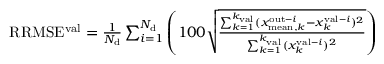Convert formula to latex. <formula><loc_0><loc_0><loc_500><loc_500>\begin{array} { r } { R R M S E ^ { v a l } = \frac { 1 } { N _ { d } } \sum _ { i = 1 } ^ { N _ { d } } \left ( 1 0 0 \sqrt { \frac { \sum _ { k = 1 } ^ { k _ { v a l } } ( x _ { m e a n , k } ^ { o u t - i } - x _ { k } ^ { v a l - i } ) ^ { 2 } } { \sum _ { k = 1 } ^ { k _ { v a l } } ( x _ { k } ^ { v a l - i } ) ^ { 2 } } } \right ) } \end{array}</formula> 